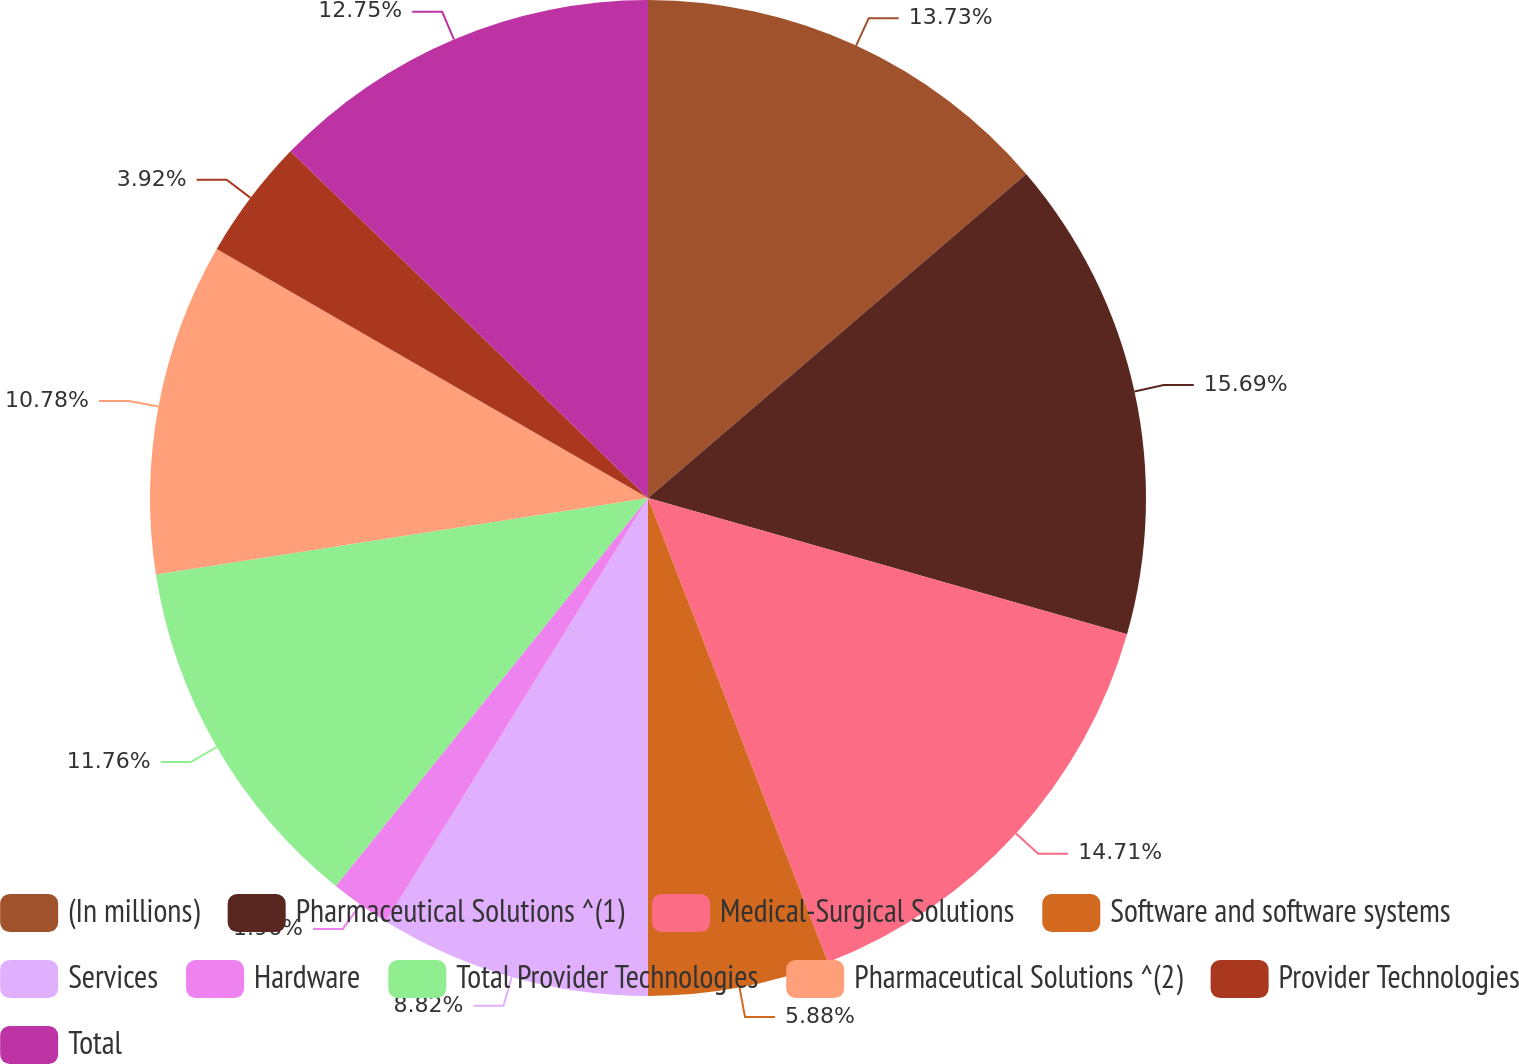<chart> <loc_0><loc_0><loc_500><loc_500><pie_chart><fcel>(In millions)<fcel>Pharmaceutical Solutions ^(1)<fcel>Medical-Surgical Solutions<fcel>Software and software systems<fcel>Services<fcel>Hardware<fcel>Total Provider Technologies<fcel>Pharmaceutical Solutions ^(2)<fcel>Provider Technologies<fcel>Total<nl><fcel>13.72%<fcel>15.68%<fcel>14.7%<fcel>5.88%<fcel>8.82%<fcel>1.96%<fcel>11.76%<fcel>10.78%<fcel>3.92%<fcel>12.74%<nl></chart> 